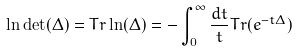<formula> <loc_0><loc_0><loc_500><loc_500>\ln \det ( \Delta ) = T r \ln ( \Delta ) = - \int _ { 0 } ^ { \infty } \frac { d t } { t } T r ( e ^ { - t \Delta } )</formula> 